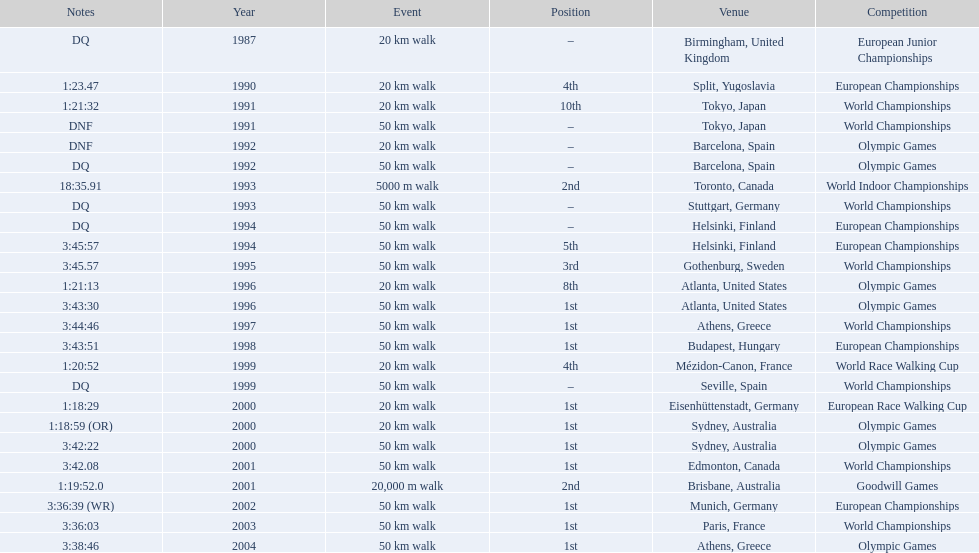In 1990 what position did robert korzeniowski place? 4th. In 1993 what was robert korzeniowski's place in the world indoor championships? 2nd. How long did the 50km walk in 2004 olympic cost? 3:38:46. 